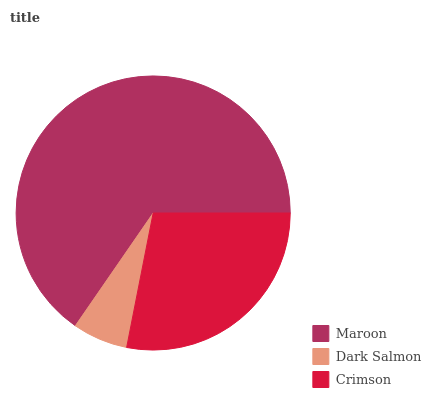Is Dark Salmon the minimum?
Answer yes or no. Yes. Is Maroon the maximum?
Answer yes or no. Yes. Is Crimson the minimum?
Answer yes or no. No. Is Crimson the maximum?
Answer yes or no. No. Is Crimson greater than Dark Salmon?
Answer yes or no. Yes. Is Dark Salmon less than Crimson?
Answer yes or no. Yes. Is Dark Salmon greater than Crimson?
Answer yes or no. No. Is Crimson less than Dark Salmon?
Answer yes or no. No. Is Crimson the high median?
Answer yes or no. Yes. Is Crimson the low median?
Answer yes or no. Yes. Is Maroon the high median?
Answer yes or no. No. Is Maroon the low median?
Answer yes or no. No. 